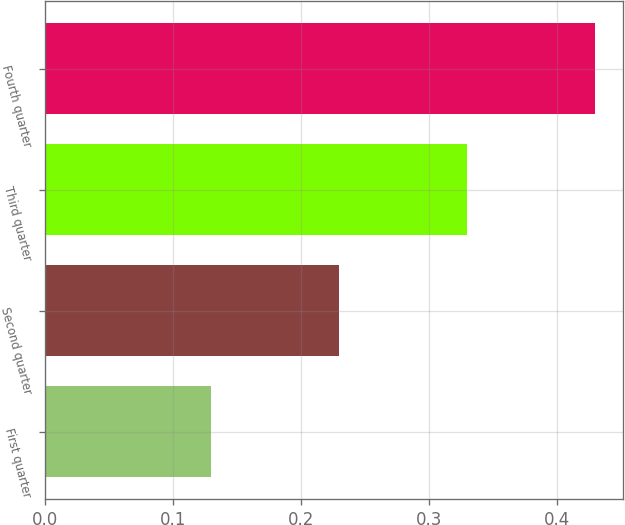<chart> <loc_0><loc_0><loc_500><loc_500><bar_chart><fcel>First quarter<fcel>Second quarter<fcel>Third quarter<fcel>Fourth quarter<nl><fcel>0.13<fcel>0.23<fcel>0.33<fcel>0.43<nl></chart> 